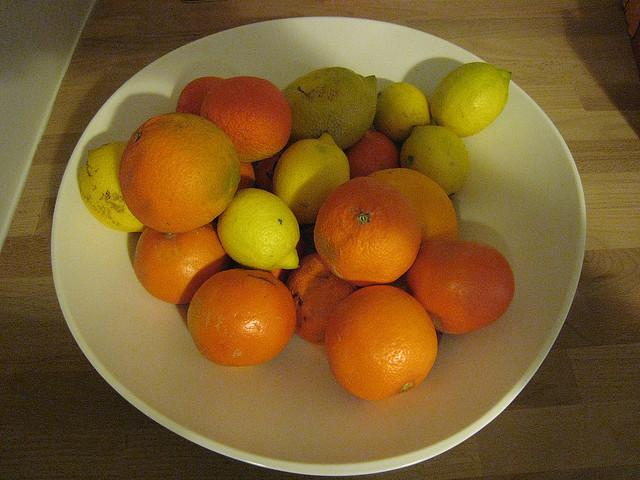Where do lemons originally come from? trees 